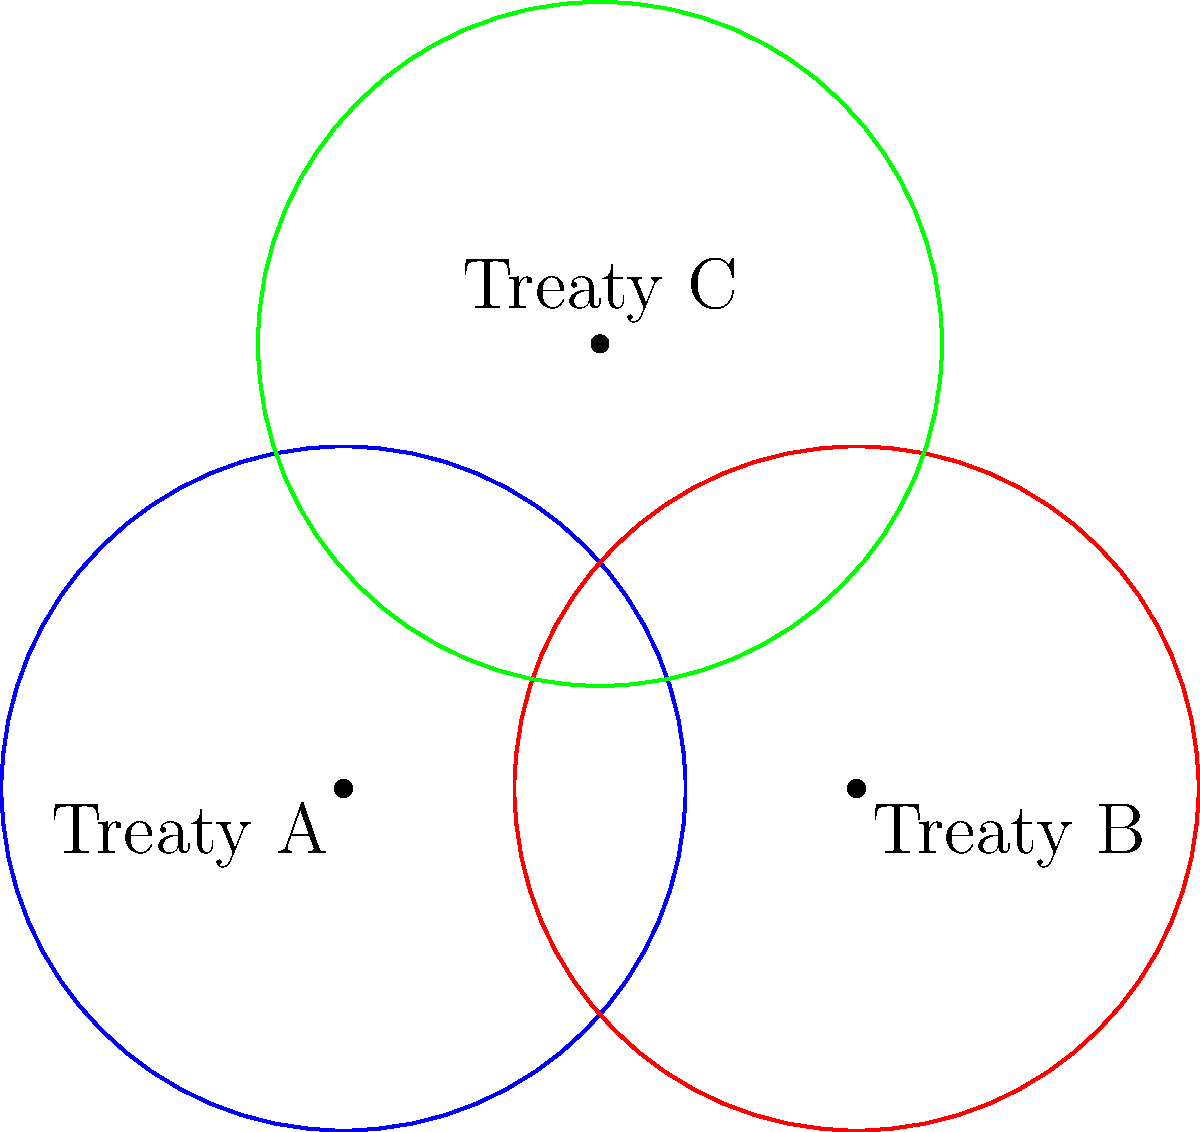In the diagram, three circles represent overlapping human rights treaties (A, B, and C), each with a radius of 1 unit. The centers of the circles form an isosceles triangle with a base of 1.5 units. Calculate the total perimeter of the outer boundary formed by the overlapping circles, rounded to two decimal places. To solve this problem, we'll follow these steps:

1) First, we need to identify the parts of the circles that form the outer boundary. These are the arcs that are not overlapped by other circles.

2) We need to calculate the central angles of these arcs:
   
   a) For circles A and B, we can use the formula: $\theta = 2 \arccos(\frac{d}{2r})$
      where $d$ is the distance between centers (1.5) and $r$ is the radius (1).
      
      $\theta = 2 \arccos(\frac{1.5}{2}) = 2.0944$ radians

   b) For circle C, we need to calculate the angle at the top of the isosceles triangle:
      Height of the triangle: $h = \sqrt{1^2 - 0.75^2} = 0.6614$
      Angle at the top: $\alpha = 2 \arctan(\frac{0.75}{0.6614}) = 2.0944$ radians

3) The central angle for the exposed arc of circle C is $2\pi - 2.0944 = 4.1888$ radians

4) Now we can calculate the lengths of these arcs:
   For circles A and B: $2 * 1 * 2.0944 = 4.1888$ units each
   For circle C: $1 * 4.1888 = 4.1888$ units

5) The total perimeter is the sum of these three arcs:
   $4.1888 + 4.1888 + 4.1888 = 12.5664$ units

6) Rounding to two decimal places: 12.57 units
Answer: 12.57 units 